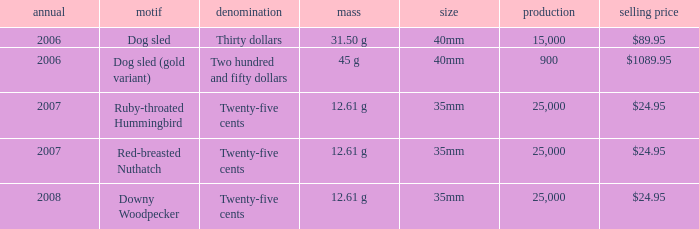What is the MIntage after 2006 of the Ruby-Throated Hummingbird Theme coin? 25000.0. 